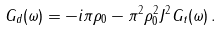Convert formula to latex. <formula><loc_0><loc_0><loc_500><loc_500>G _ { d } ( \omega ) = - i \pi \rho _ { 0 } - \pi ^ { 2 } \rho _ { 0 } ^ { 2 } J ^ { 2 } G _ { t } ( \omega ) \, .</formula> 